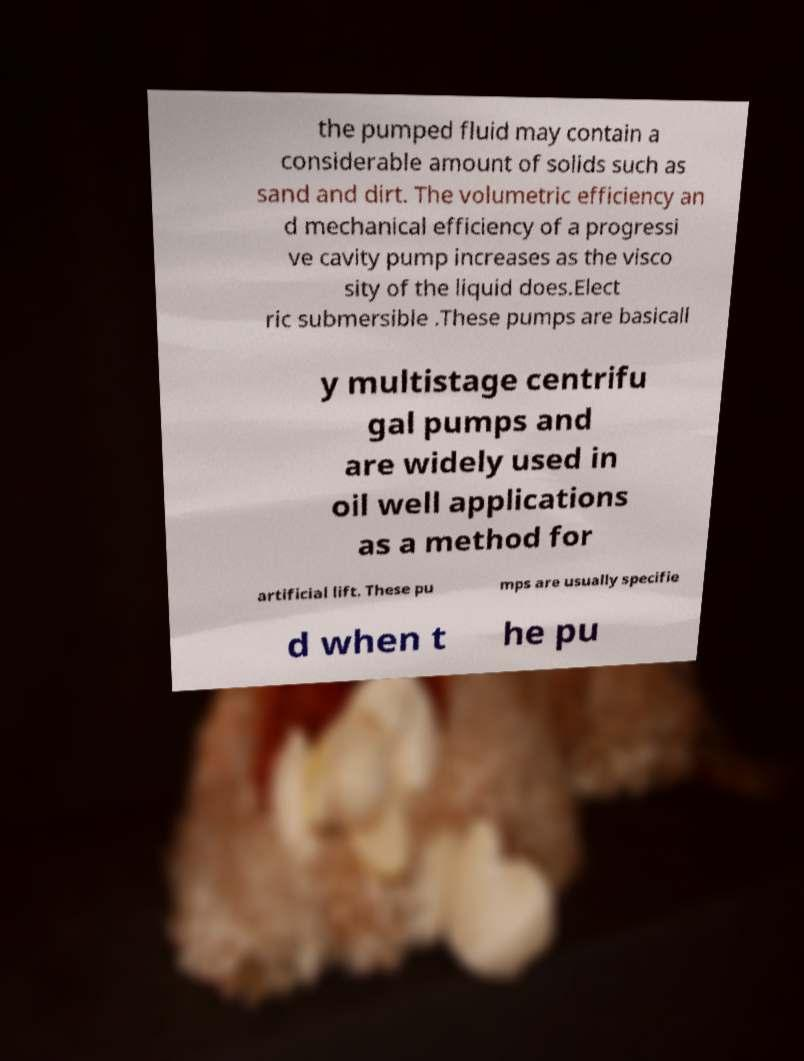Please read and relay the text visible in this image. What does it say? the pumped fluid may contain a considerable amount of solids such as sand and dirt. The volumetric efficiency an d mechanical efficiency of a progressi ve cavity pump increases as the visco sity of the liquid does.Elect ric submersible .These pumps are basicall y multistage centrifu gal pumps and are widely used in oil well applications as a method for artificial lift. These pu mps are usually specifie d when t he pu 